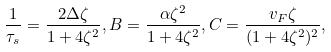<formula> <loc_0><loc_0><loc_500><loc_500>\frac { 1 } { \tau _ { s } } = \frac { 2 \Delta \zeta } { 1 + 4 \zeta ^ { 2 } } , B = \frac { \alpha \zeta ^ { 2 } } { 1 + 4 \zeta ^ { 2 } } , C = \frac { v _ { F } \zeta } { ( 1 + 4 \zeta ^ { 2 } ) ^ { 2 } } ,</formula> 